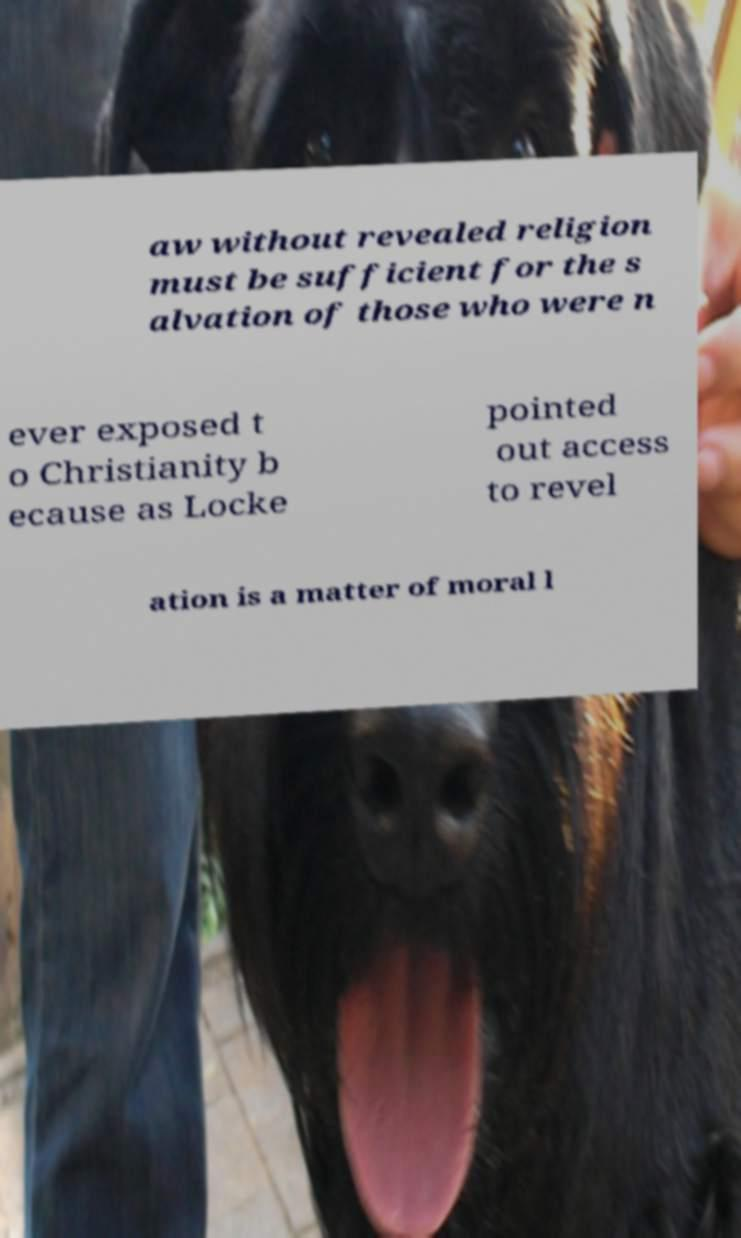What messages or text are displayed in this image? I need them in a readable, typed format. aw without revealed religion must be sufficient for the s alvation of those who were n ever exposed t o Christianity b ecause as Locke pointed out access to revel ation is a matter of moral l 